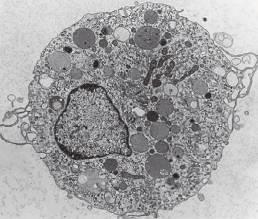when are the majority of tissue macrophages derived from hematopoietic precursors?
Answer the question using a single word or phrase. During inflammatory reactions 